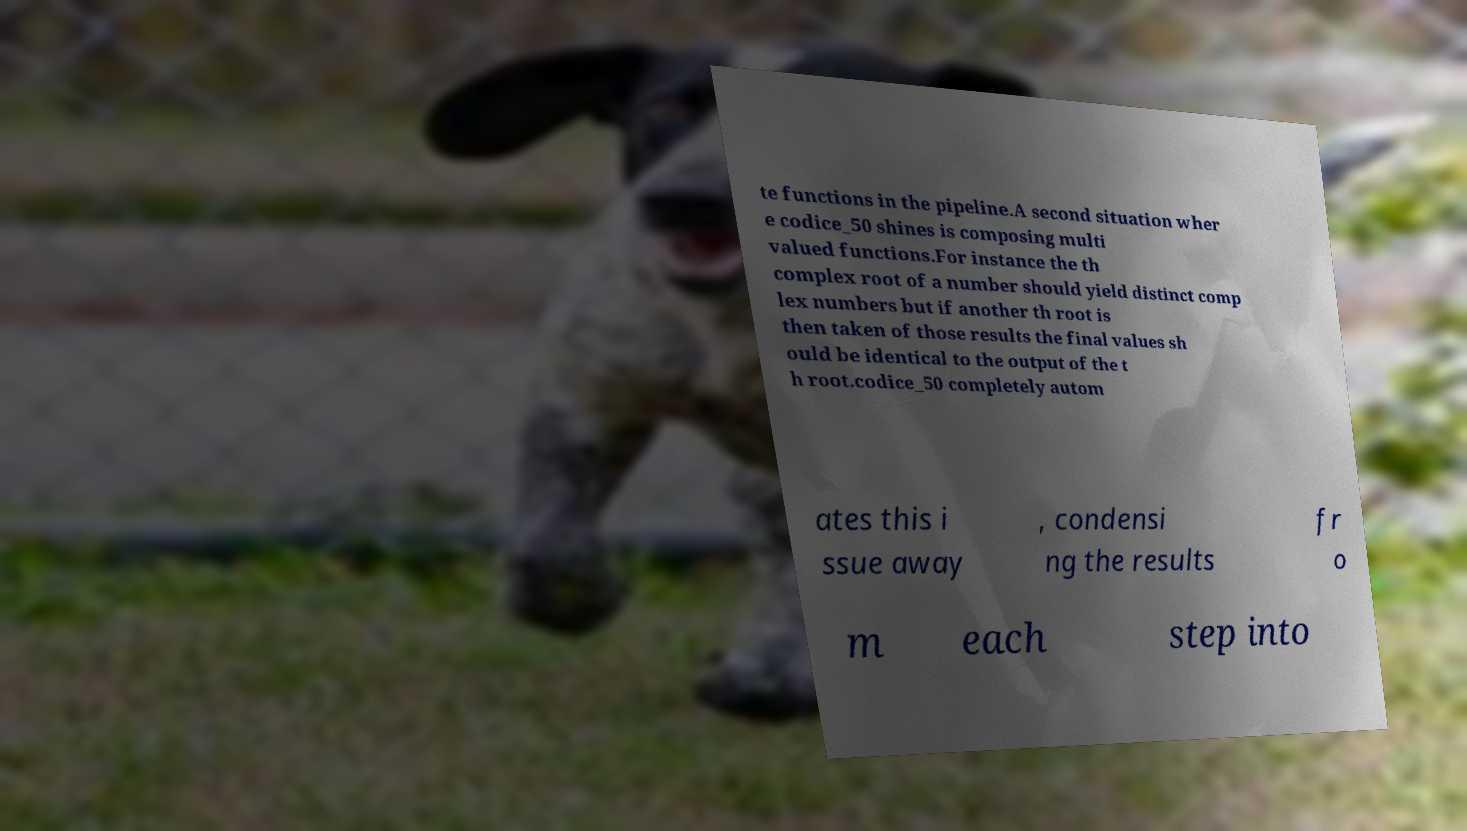Can you accurately transcribe the text from the provided image for me? te functions in the pipeline.A second situation wher e codice_50 shines is composing multi valued functions.For instance the th complex root of a number should yield distinct comp lex numbers but if another th root is then taken of those results the final values sh ould be identical to the output of the t h root.codice_50 completely autom ates this i ssue away , condensi ng the results fr o m each step into 